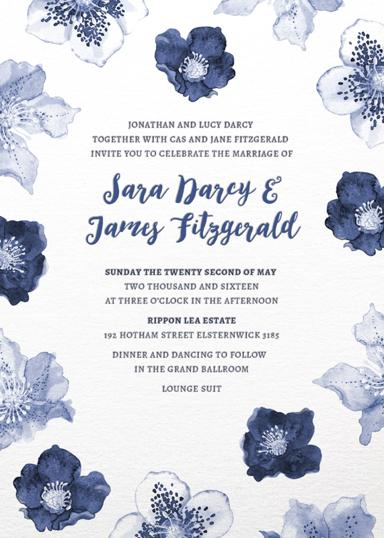What are the considerations for the lounge suit dress code at this wedding? The lounge suit dress code suggests a semi-formal approach, emphasizing comfort and style. It typically involves a suit and tie for men and a classy yet practical dress for women, suitable for both the ceremony and the evening festivities. 